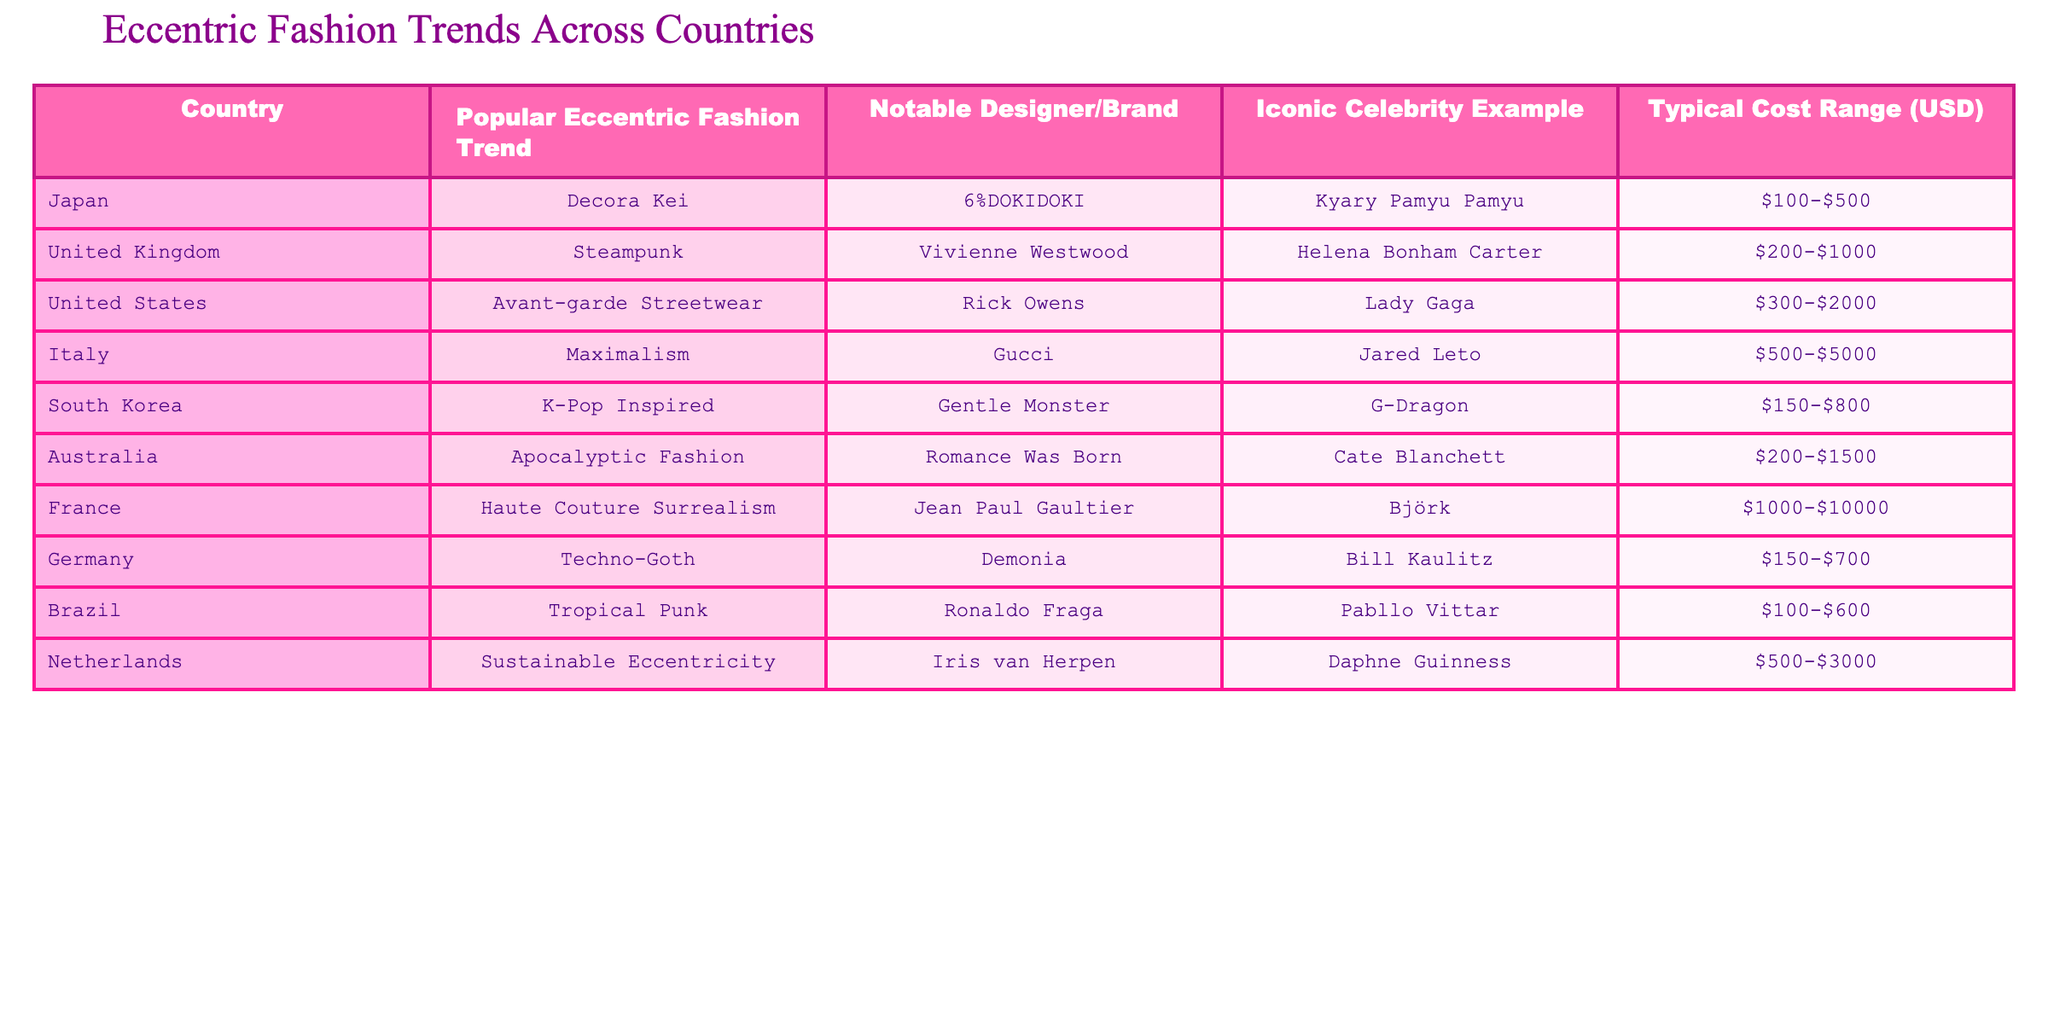What is the popular eccentric fashion trend in Japan? Referring to the table, the listed popular eccentric fashion trend in Japan is Decora Kei.
Answer: Decora Kei Who is the notable designer for the K-Pop inspired trend in South Korea? In the table, it states that the notable designer for the K-Pop Inspired trend in South Korea is Gentle Monster.
Answer: Gentle Monster Which country has the highest typical cost range for eccentric fashion trends, according to the table? Looking at the cost ranges provided, France has the highest typical cost range of $1000-$10000.
Answer: France Is Helena Bonham Carter associated with any fashion trend listed? The table indicates that Helena Bonham Carter is associated with the Steampunk fashion trend from the United Kingdom, confirming the fact as true.
Answer: Yes What is the cost range for the popular eccentric fashion trend in Brazil? The table shows that the typical cost range for the Tropical Punk trend in Brazil is $100-$600.
Answer: $100-$600 Which fashion trend is associated with the United States, and who is the iconic celebrity example? The table specifies that the Avant-garde Streetwear trend is associated with the United States, and the iconic celebrity example is Lady Gaga.
Answer: Avant-garde Streetwear, Lady Gaga How many countries have a typical cost range above $1000? By analyzing the table, we can count France and Italy as having a cost range above $1000, which totals to 2 countries.
Answer: 2 What fashion trend does the designer Vivienne Westwood represent and what is its cost range? The table indicates Vivienne Westwood is associated with the Steampunk trend, which has a cost range of $200-$1000.
Answer: Steampunk, $200-$1000 Which country's fashion trend features an iconic celebrity example who is a musician? The table reveals that countries such as South Korea (G-Dragon) and Brazil (Pabllo Vittar) feature musicians as iconic celebrity examples in their fashion trends.
Answer: South Korea, Brazil If we consider the average typical cost range of Italy and the United States, what would it be? Italy has a cost range of $500-$5000 and the United States has $300-$2000. If we take the average of the lower bounds (500 and 300) and upper bounds (5000 and 2000), the average lower cost is $400 and the upper is $3500, hence the average range is $400-$3500.
Answer: $400-$3500 